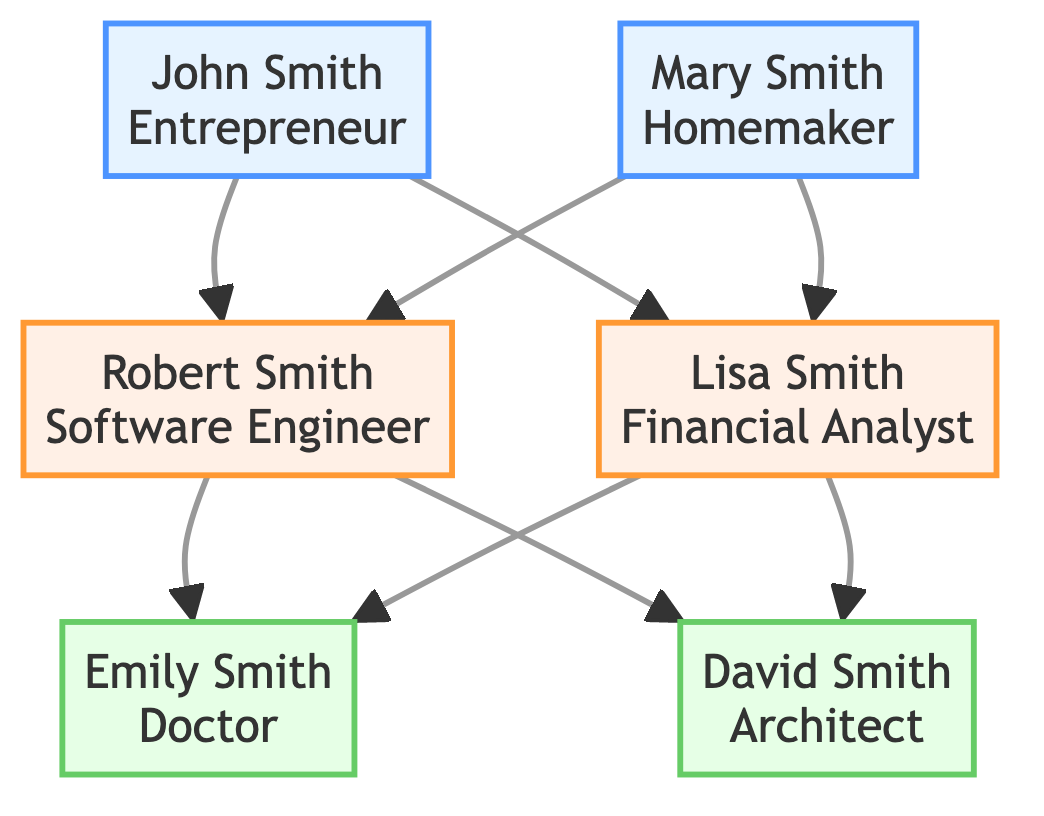What is the career path of John Smith? According to the diagram, John Smith is depicted as an Entrepreneur. This information is directly stated in the node representing him.
Answer: Entrepreneur How many children does Robert Smith have? The diagram shows two nodes connected to Robert Smith, who are Emily Smith and David Smith, indicating he has two children.
Answer: 2 What year did Lisa Smith become Vice President? The diagram indicates that Lisa Smith was promoted to Vice President in 2015, as stated in the milestones associated with her career path.
Answer: 2015 Who is the mother of David Smith? To find the answer, we look at the diagram and note that David Smith is connected to Lisa Smith and Robert Smith as parents. Therefore, Lisa Smith is David's mother.
Answer: Lisa Smith Which career path was pursued by the daughter of Robert Smith? Looking at the diagram, we can see that Robert Smith is the father of Emily Smith, who has a career path as a Doctor. This is found in the node for Emily Smith.
Answer: Doctor What milestone did John Smith achieve in 1975? According to the milestone details provided for John Smith, in 1975 he expanded his business to three locations, a key event in his career path.
Answer: Expanded business to three locations What was Robert Smith’s first milestone after obtaining his degree? The first significant career event after Robert Smith graduated in 1990 is joining Google as a Senior Developer in 2000, following a span of time post-graduation where he likely gained experience.
Answer: Joined Google as a Senior Developer How is Mary Smith related to David Smith? The diagram illustrates that Mary Smith is the grandmother of David Smith, as she is connected to Robert Smith and Lisa Smith, who are David’s parents.
Answer: Grandmother What is the profession of the child born to Robert and Lisa Smith? Examining the diagram, both children of Robert and Lisa Smith, Emily Smith and David Smith, have careers. David Smith's profession is Architect, located in the node pertaining to him.
Answer: Architect 